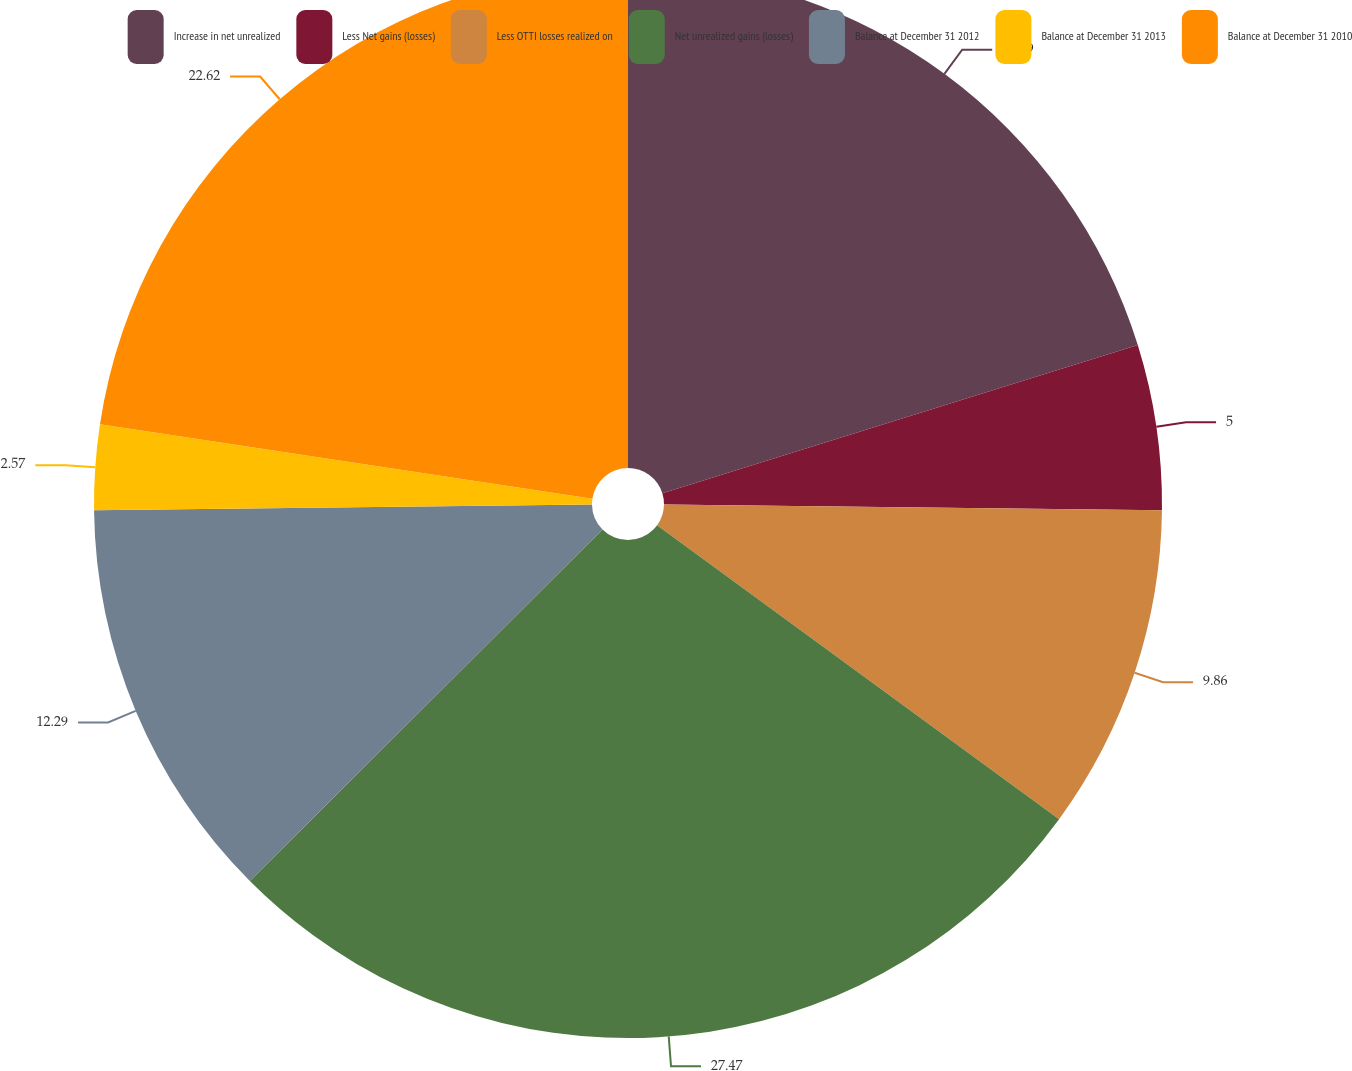Convert chart. <chart><loc_0><loc_0><loc_500><loc_500><pie_chart><fcel>Increase in net unrealized<fcel>Less Net gains (losses)<fcel>Less OTTI losses realized on<fcel>Net unrealized gains (losses)<fcel>Balance at December 31 2012<fcel>Balance at December 31 2013<fcel>Balance at December 31 2010<nl><fcel>20.19%<fcel>5.0%<fcel>9.86%<fcel>27.48%<fcel>12.29%<fcel>2.57%<fcel>22.62%<nl></chart> 